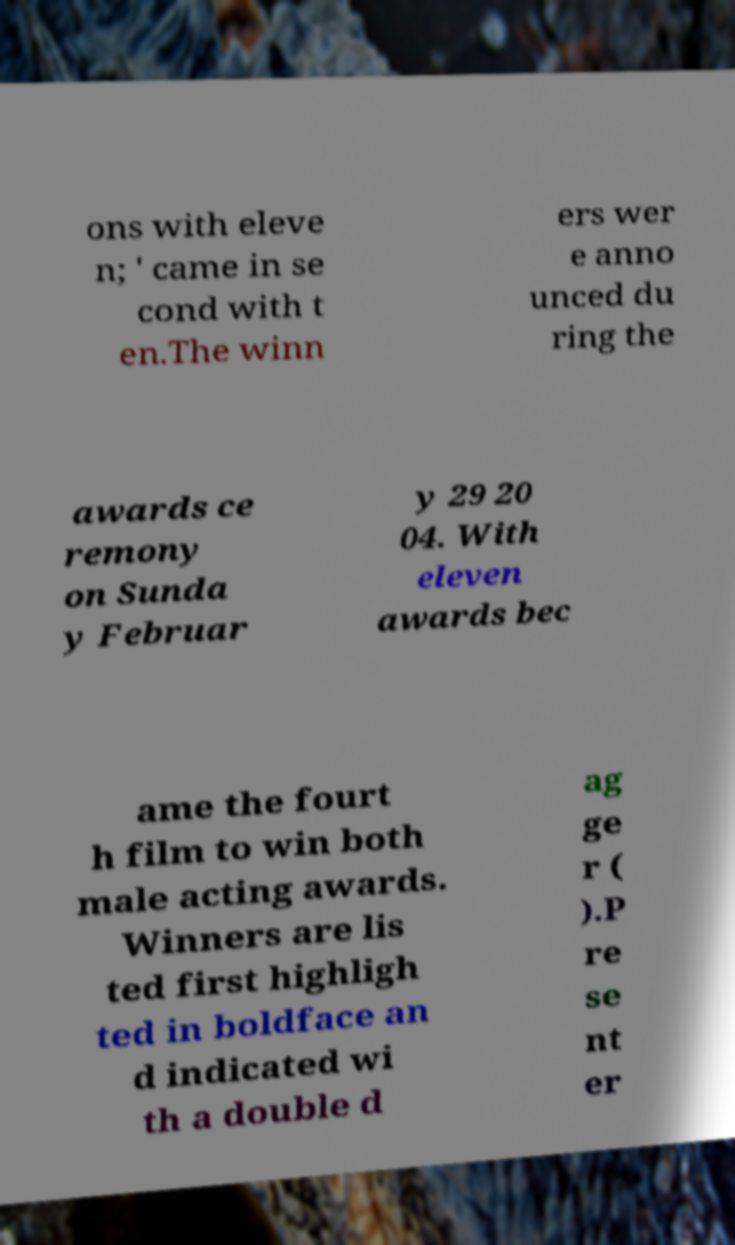Can you accurately transcribe the text from the provided image for me? ons with eleve n; ' came in se cond with t en.The winn ers wer e anno unced du ring the awards ce remony on Sunda y Februar y 29 20 04. With eleven awards bec ame the fourt h film to win both male acting awards. Winners are lis ted first highligh ted in boldface an d indicated wi th a double d ag ge r ( ).P re se nt er 